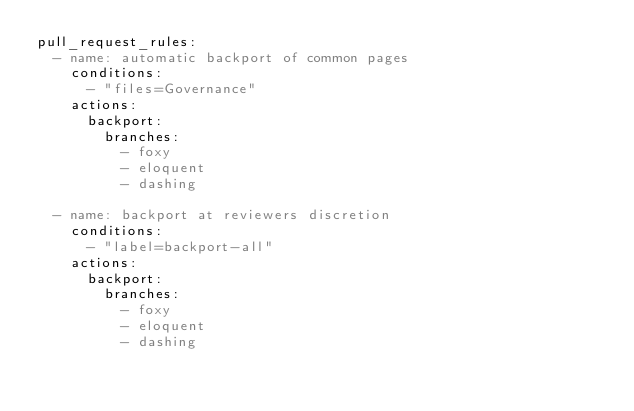Convert code to text. <code><loc_0><loc_0><loc_500><loc_500><_YAML_>pull_request_rules:
  - name: automatic backport of common pages
    conditions:
      - "files=Governance"
    actions:
      backport:
        branches:
          - foxy
          - eloquent
          - dashing
          
  - name: backport at reviewers discretion 
    conditions:
      - "label=backport-all"
    actions:
      backport:
        branches:
          - foxy
          - eloquent
          - dashing
</code> 